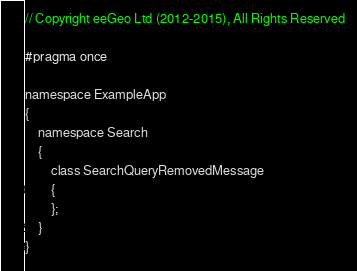Convert code to text. <code><loc_0><loc_0><loc_500><loc_500><_C_>// Copyright eeGeo Ltd (2012-2015), All Rights Reserved

#pragma once

namespace ExampleApp
{
    namespace Search
    {
        class SearchQueryRemovedMessage
        {
        };
    }
}
</code> 